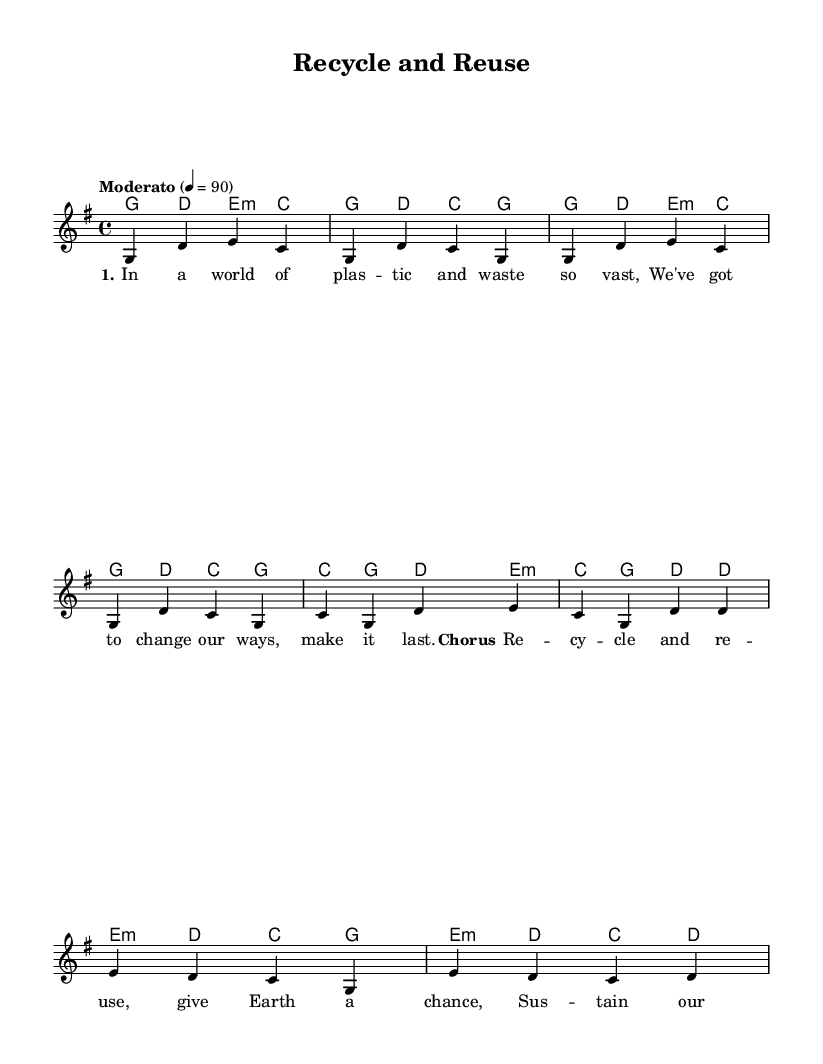What is the key signature of this music? The key signature is G major, which has one sharp (F#). This can be determined by looking at the key signature at the beginning of the score.
Answer: G major What is the time signature of this music? The time signature is 4/4, which can be identified through the top left of the sheet music where the time signature is indicated. Each measure consists of four beats.
Answer: 4/4 What is the tempo marking of the piece? The tempo is marked as "Moderato", indicating a moderate speed, which typically ranges from 108 to 120 beats per minute. This can be found at the top of the score just after the key signature.
Answer: Moderato How many verses are shown in the music? There is one complete verse shown in the music, as indicated by the lyrics in the "verseOne" section before the chorus. No additional verses are provided in the notation.
Answer: One What is the primary theme of the lyrics provided? The primary theme of the lyrics revolves around recycling and sustainability, as seen in both the verse and chorus focusing on environmental awareness. This theme is consistent with the title of the piece.
Answer: Recycling and sustainability What is the chord used in the bridge? The chords indicated for the bridge section include e minor and d major, which are mentioned in the harmonies part of the score where the bridge lyrics are set.
Answer: e minor 